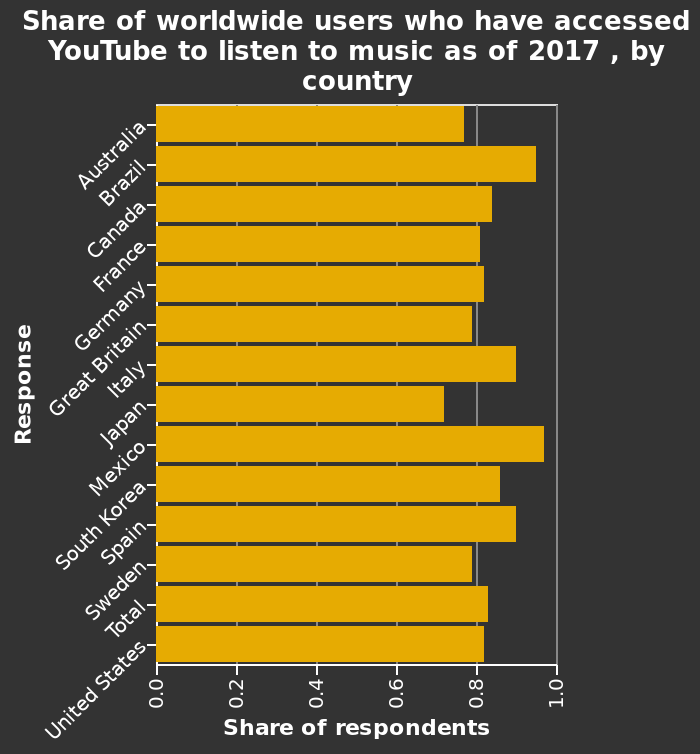<image>
Which country has the lowest share of respondents? The country with the lowest share of respondents is Japan. What are the top two countries with the highest share of respondents? The top two countries with the highest share of respondents are Mexico and Brazil. What year does the data represent? The data represents the share of worldwide users accessing YouTube for music listening as of 2017. What scale is used for the y-axis?  The y-axis uses a categorical scale from Australia to United States, labeled as Response. Which countries have a higher share of respondents than the total? The countries with a higher share of respondents than the total are Spain, South Korea, Mexico, Brazil, Italy, and Canada. 